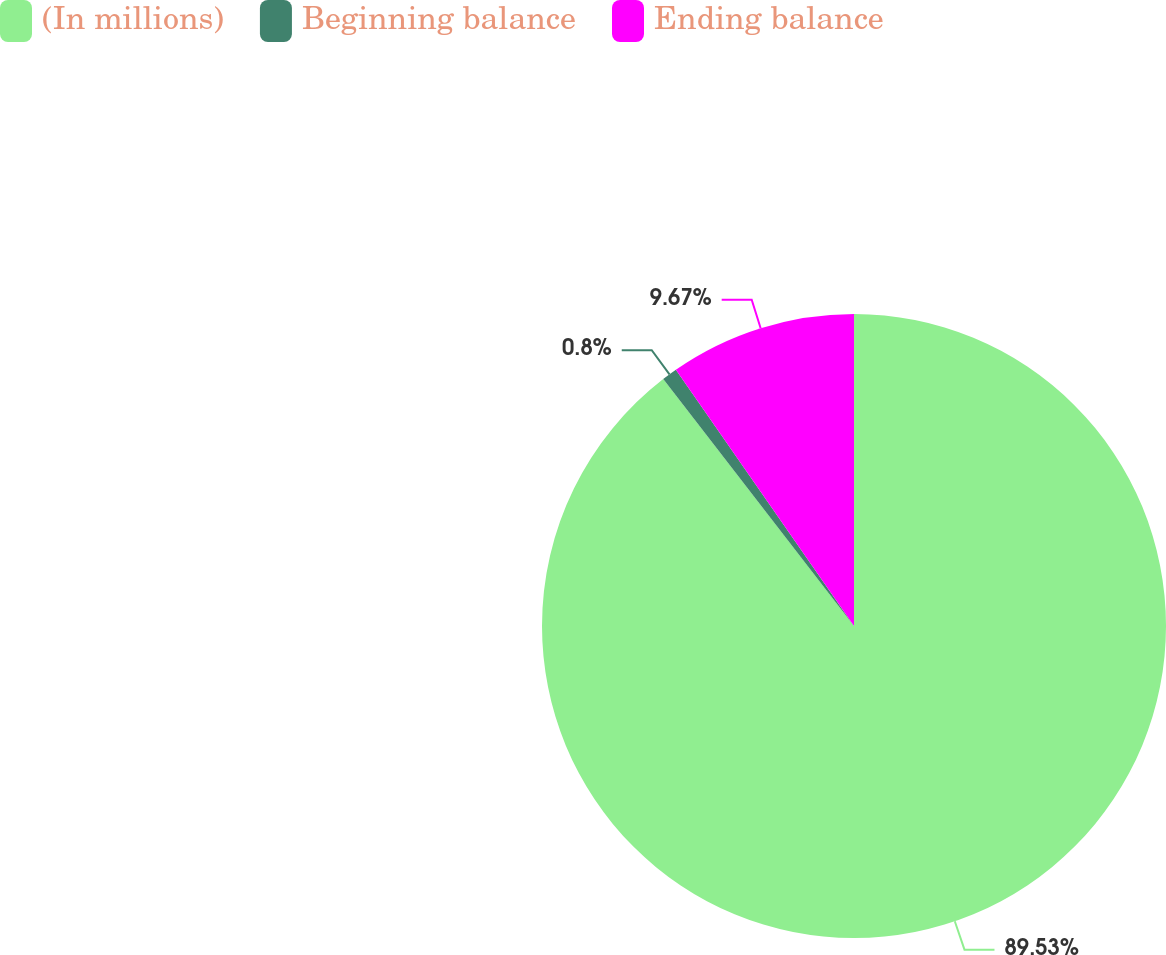Convert chart to OTSL. <chart><loc_0><loc_0><loc_500><loc_500><pie_chart><fcel>(In millions)<fcel>Beginning balance<fcel>Ending balance<nl><fcel>89.52%<fcel>0.8%<fcel>9.67%<nl></chart> 